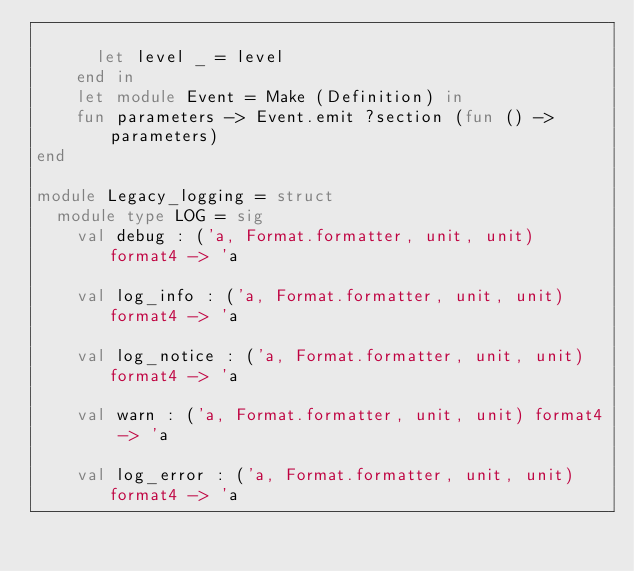Convert code to text. <code><loc_0><loc_0><loc_500><loc_500><_OCaml_>
      let level _ = level
    end in
    let module Event = Make (Definition) in
    fun parameters -> Event.emit ?section (fun () -> parameters)
end

module Legacy_logging = struct
  module type LOG = sig
    val debug : ('a, Format.formatter, unit, unit) format4 -> 'a

    val log_info : ('a, Format.formatter, unit, unit) format4 -> 'a

    val log_notice : ('a, Format.formatter, unit, unit) format4 -> 'a

    val warn : ('a, Format.formatter, unit, unit) format4 -> 'a

    val log_error : ('a, Format.formatter, unit, unit) format4 -> 'a
</code> 